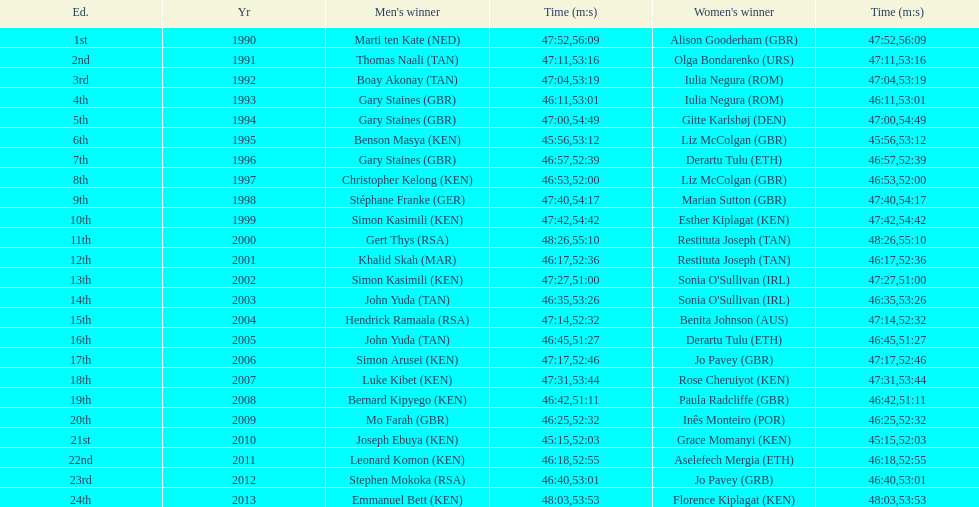The other women's winner with the same finish time as jo pavey in 2012 Iulia Negura. 